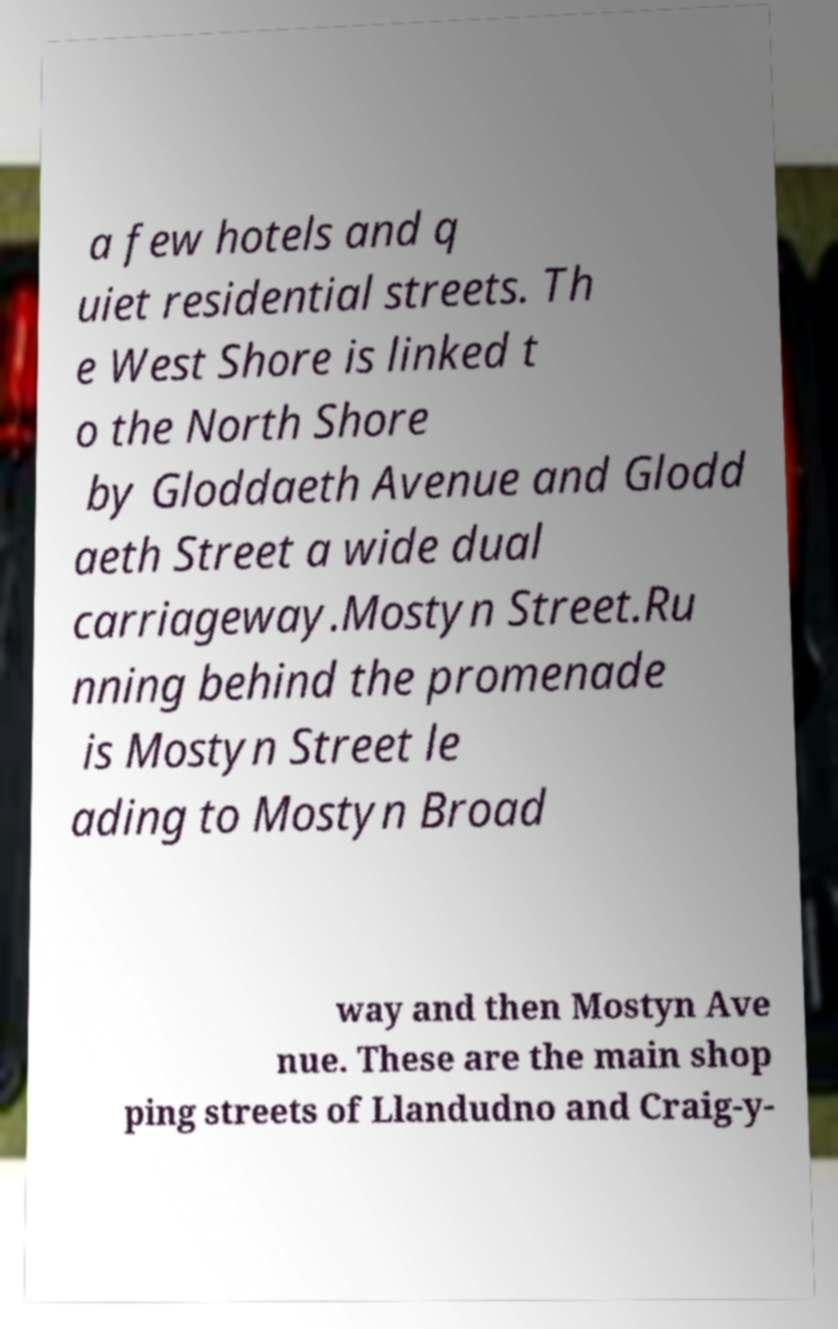Can you accurately transcribe the text from the provided image for me? a few hotels and q uiet residential streets. Th e West Shore is linked t o the North Shore by Gloddaeth Avenue and Glodd aeth Street a wide dual carriageway.Mostyn Street.Ru nning behind the promenade is Mostyn Street le ading to Mostyn Broad way and then Mostyn Ave nue. These are the main shop ping streets of Llandudno and Craig-y- 